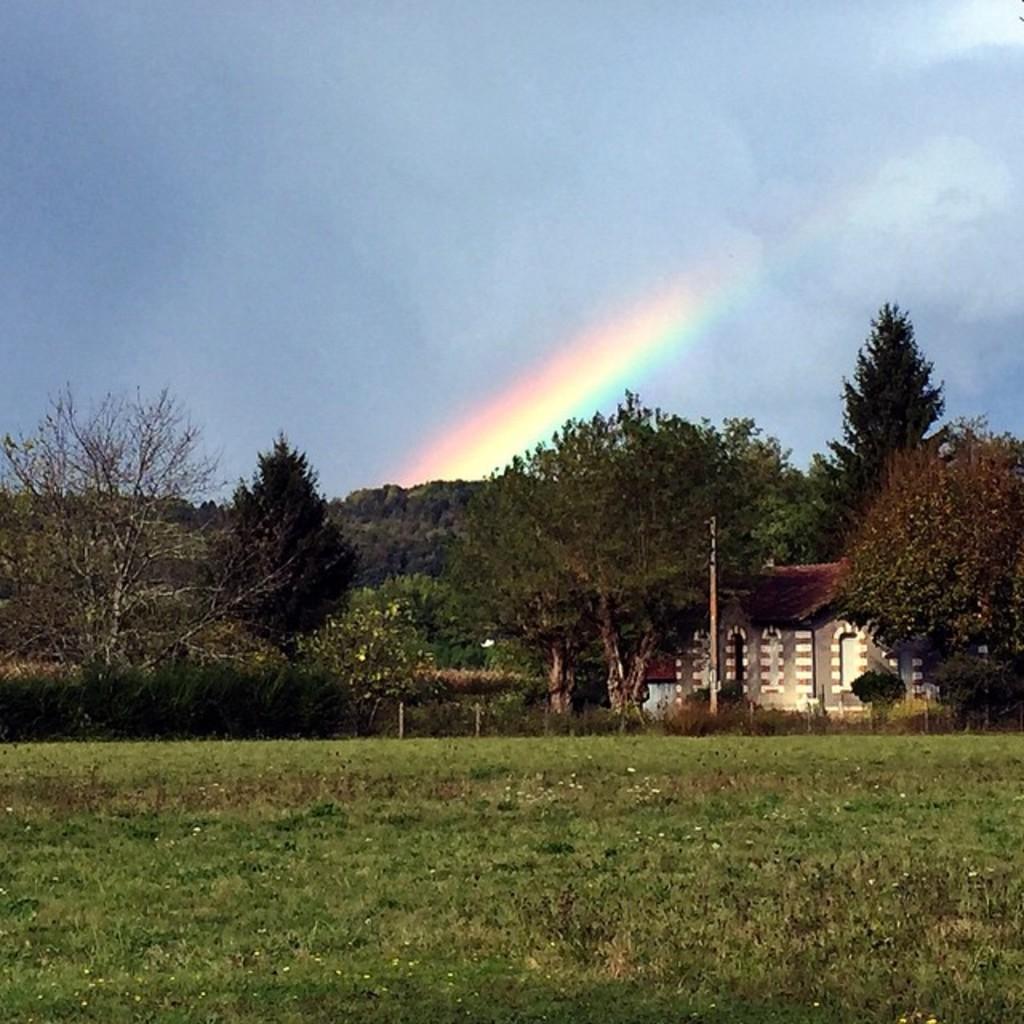Please provide a concise description of this image. In this image we can see trees, plants, building and grassy land. In the background, we can see a rainbow and the sky. 